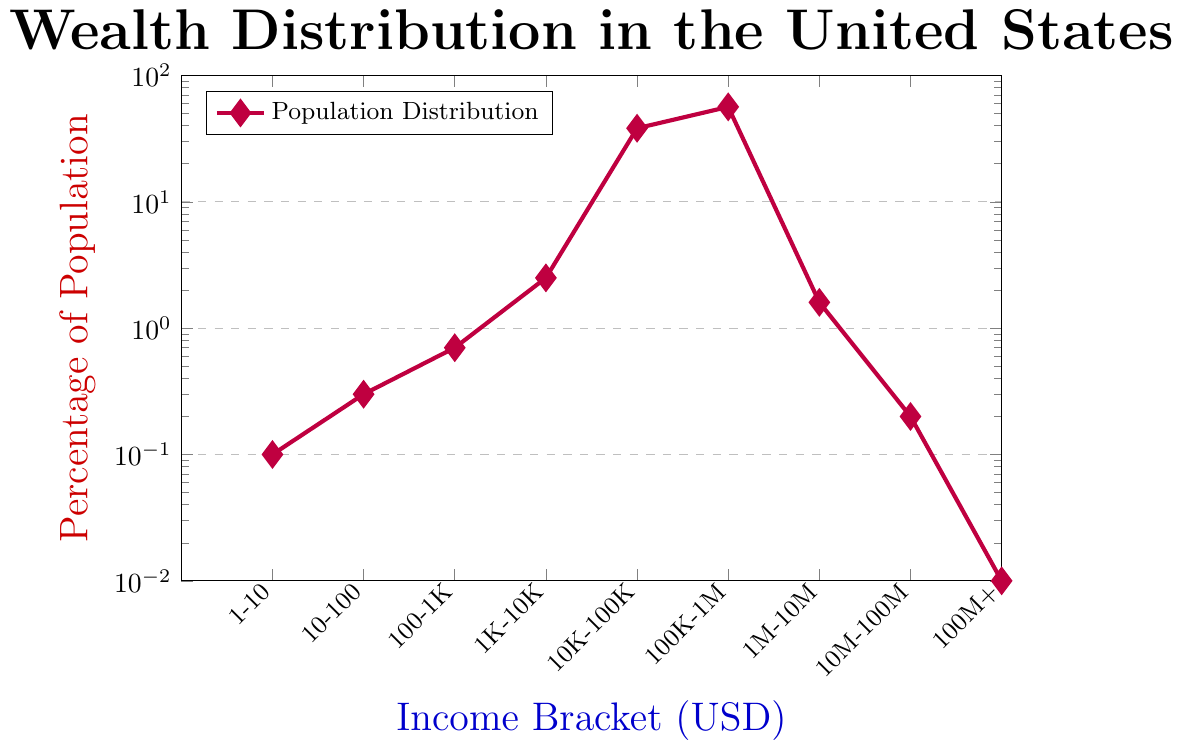Which income bracket has the highest percentage of the population? By observing the y-axis, we see that the income bracket labeled "100K-1M" (which is the sixth point on the x-axis) has the highest y-value at 56.4%.
Answer: 100K-1M How many income brackets have a population percentage above 1%? To answer this, we count the points on the plot where the y-value is greater than 1%. The brackets are 100-1K (0.7%), 1K-10K (2.5%), 10K-100K (38.2%), and 100K-1M (56.4%), so there are 4 brackets.
Answer: 4 What is the difference in population percentage between the "10K-100K" and "1M-10M" income brackets? The "10K-100K" bracket has a population percentage of 38.2%, and the "1M-10M" bracket has 1.6%. The difference is 38.2% - 1.6% = 36.6%.
Answer: 36.6% Which income bracket corresponds to a population percentage of 0.3%? By observing the plot, we see that the second point on the x-axis corresponds to 0.3%, which is the "10-100" income bracket.
Answer: 10-100 Is the percentage of the population with an income bracket of "100K-1M" greater or lesser than the sum of percentages of all people in income brackets "1-10" and "10-100"? The percentage of the "100K-1M" bracket is 56.4%. The sum of the "1-10" and "10-100" brackets is 0.1% + 0.3% = 0.4%. Clearly, 56.4% is greater than 0.4%.
Answer: Greater What is the combined percentage of the population in the "1-10", "10-100", and "100-1K" brackets? The populations are 0.1%, 0.3%, and 0.7%, respectively. Their sum is 0.1% + 0.3% + 0.7% = 1.1%.
Answer: 1.1% Compare the population percentage between the "1K-10K" income bracket and the "100-1K" income bracket. Which is higher? By observing the plot, the "1K-10K" bracket has a percentage of 2.5%, while the "100-1K" bracket has 0.7%. Therefore, "1K-10K" is higher.
Answer: 1K-10K For what income bracket is the population percentage 0.01%? By observing the plot, we find that the ninth point on the x-axis corresponds to a population percentage of 0.01%. This is the "100M+" income bracket.
Answer: 100M+ How many income brackets have less than or equal to 0.2% of the population? The points with percentages less than or equal to 0.2% are "1-10" (0.1%), "10-100" (0.3%), "1M-10M" (1.6%), "10M-100M" (0.2%), and "100M+" (0.01%), totaling 4 brackets.
Answer: 4 